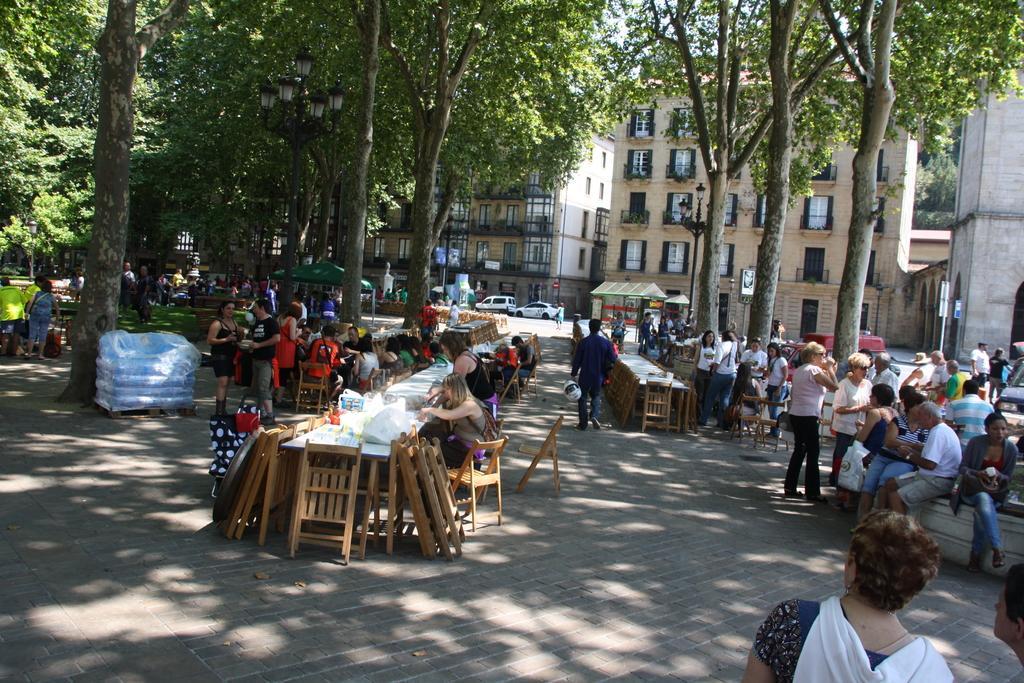Describe this image in one or two sentences. In the image we can see there are people who are sitting on chairs and few people are standing on the road and behind them there are lot of trees and buildings. 